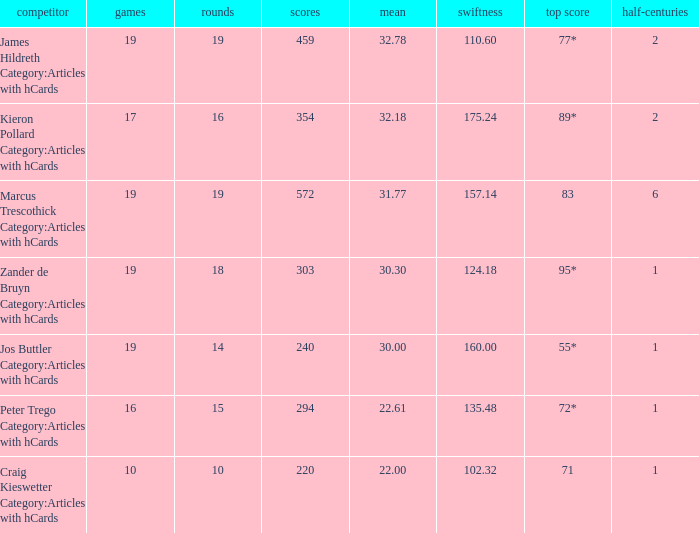How many innings for the player with an average of 22.61? 15.0. 